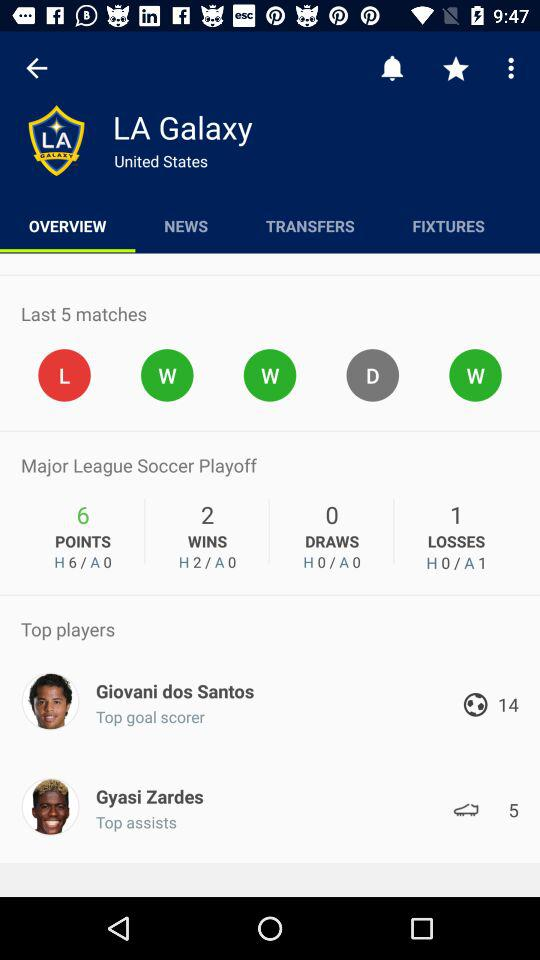What team does Giovani dos Santos play for in this image? In the image, Giovani dos Santos is shown as a top player for LA Galaxy, indicated by the club logo displayed at the top of the screen. 